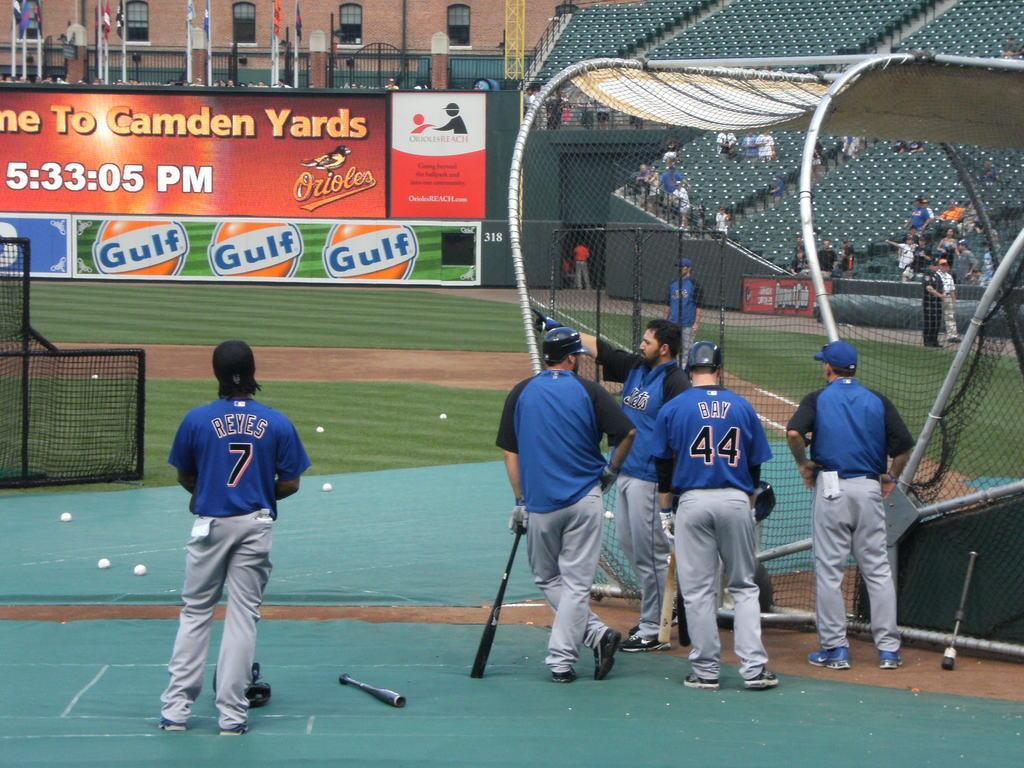Can you describe this image briefly? This picture describes about group of people, few people are seated and few are standing, in the middle of the image we can see few people, and few persons are holding bats, in front of them we can find a net and few balls, in the background we can see few hoardings, poles and a building. 